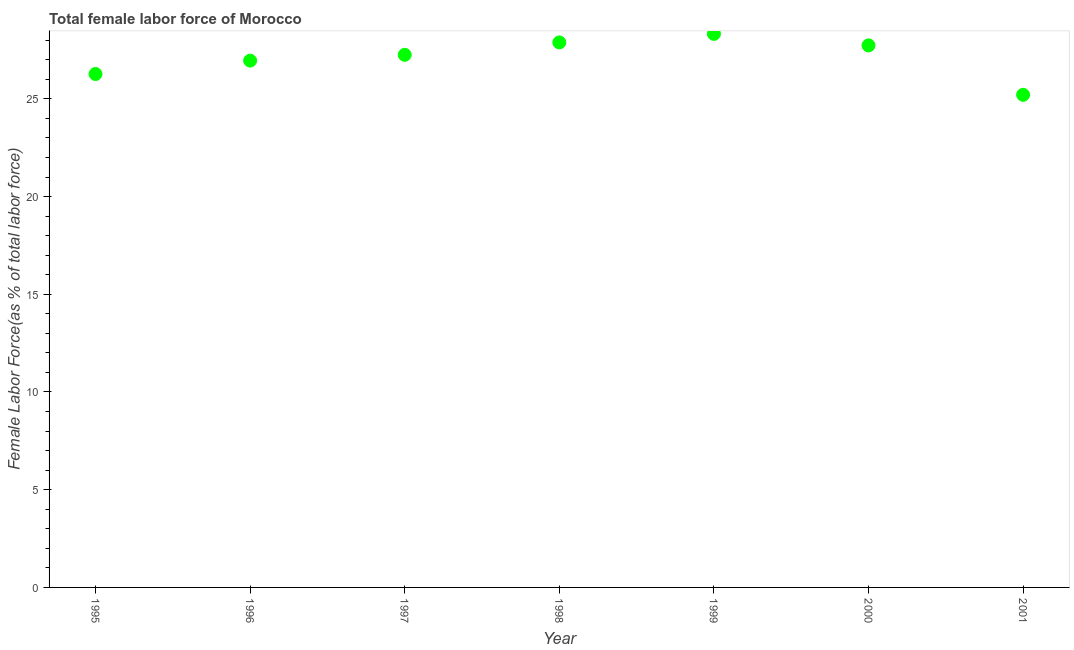What is the total female labor force in 1998?
Your answer should be very brief. 27.89. Across all years, what is the maximum total female labor force?
Offer a very short reply. 28.33. Across all years, what is the minimum total female labor force?
Your answer should be very brief. 25.21. In which year was the total female labor force maximum?
Ensure brevity in your answer.  1999. What is the sum of the total female labor force?
Provide a short and direct response. 189.64. What is the difference between the total female labor force in 1997 and 1998?
Your answer should be compact. -0.64. What is the average total female labor force per year?
Provide a short and direct response. 27.09. What is the median total female labor force?
Offer a very short reply. 27.25. Do a majority of the years between 2001 and 1998 (inclusive) have total female labor force greater than 16 %?
Your response must be concise. Yes. What is the ratio of the total female labor force in 1995 to that in 1999?
Provide a short and direct response. 0.93. Is the total female labor force in 1999 less than that in 2000?
Ensure brevity in your answer.  No. What is the difference between the highest and the second highest total female labor force?
Keep it short and to the point. 0.44. What is the difference between the highest and the lowest total female labor force?
Your response must be concise. 3.12. Does the total female labor force monotonically increase over the years?
Your answer should be very brief. No. How many dotlines are there?
Your answer should be very brief. 1. What is the difference between two consecutive major ticks on the Y-axis?
Provide a short and direct response. 5. Does the graph contain any zero values?
Your answer should be compact. No. Does the graph contain grids?
Offer a very short reply. No. What is the title of the graph?
Provide a succinct answer. Total female labor force of Morocco. What is the label or title of the X-axis?
Provide a short and direct response. Year. What is the label or title of the Y-axis?
Ensure brevity in your answer.  Female Labor Force(as % of total labor force). What is the Female Labor Force(as % of total labor force) in 1995?
Offer a very short reply. 26.27. What is the Female Labor Force(as % of total labor force) in 1996?
Make the answer very short. 26.96. What is the Female Labor Force(as % of total labor force) in 1997?
Your answer should be very brief. 27.25. What is the Female Labor Force(as % of total labor force) in 1998?
Give a very brief answer. 27.89. What is the Female Labor Force(as % of total labor force) in 1999?
Make the answer very short. 28.33. What is the Female Labor Force(as % of total labor force) in 2000?
Provide a short and direct response. 27.74. What is the Female Labor Force(as % of total labor force) in 2001?
Your answer should be compact. 25.21. What is the difference between the Female Labor Force(as % of total labor force) in 1995 and 1996?
Offer a very short reply. -0.69. What is the difference between the Female Labor Force(as % of total labor force) in 1995 and 1997?
Keep it short and to the point. -0.98. What is the difference between the Female Labor Force(as % of total labor force) in 1995 and 1998?
Keep it short and to the point. -1.62. What is the difference between the Female Labor Force(as % of total labor force) in 1995 and 1999?
Provide a short and direct response. -2.05. What is the difference between the Female Labor Force(as % of total labor force) in 1995 and 2000?
Make the answer very short. -1.46. What is the difference between the Female Labor Force(as % of total labor force) in 1995 and 2001?
Ensure brevity in your answer.  1.06. What is the difference between the Female Labor Force(as % of total labor force) in 1996 and 1997?
Keep it short and to the point. -0.3. What is the difference between the Female Labor Force(as % of total labor force) in 1996 and 1998?
Ensure brevity in your answer.  -0.93. What is the difference between the Female Labor Force(as % of total labor force) in 1996 and 1999?
Your answer should be very brief. -1.37. What is the difference between the Female Labor Force(as % of total labor force) in 1996 and 2000?
Offer a terse response. -0.78. What is the difference between the Female Labor Force(as % of total labor force) in 1996 and 2001?
Your response must be concise. 1.75. What is the difference between the Female Labor Force(as % of total labor force) in 1997 and 1998?
Your answer should be compact. -0.64. What is the difference between the Female Labor Force(as % of total labor force) in 1997 and 1999?
Provide a short and direct response. -1.07. What is the difference between the Female Labor Force(as % of total labor force) in 1997 and 2000?
Provide a short and direct response. -0.48. What is the difference between the Female Labor Force(as % of total labor force) in 1997 and 2001?
Offer a very short reply. 2.05. What is the difference between the Female Labor Force(as % of total labor force) in 1998 and 1999?
Your response must be concise. -0.44. What is the difference between the Female Labor Force(as % of total labor force) in 1998 and 2000?
Your response must be concise. 0.15. What is the difference between the Female Labor Force(as % of total labor force) in 1998 and 2001?
Offer a terse response. 2.68. What is the difference between the Female Labor Force(as % of total labor force) in 1999 and 2000?
Your answer should be compact. 0.59. What is the difference between the Female Labor Force(as % of total labor force) in 1999 and 2001?
Make the answer very short. 3.12. What is the difference between the Female Labor Force(as % of total labor force) in 2000 and 2001?
Your answer should be very brief. 2.53. What is the ratio of the Female Labor Force(as % of total labor force) in 1995 to that in 1998?
Ensure brevity in your answer.  0.94. What is the ratio of the Female Labor Force(as % of total labor force) in 1995 to that in 1999?
Offer a terse response. 0.93. What is the ratio of the Female Labor Force(as % of total labor force) in 1995 to that in 2000?
Offer a terse response. 0.95. What is the ratio of the Female Labor Force(as % of total labor force) in 1995 to that in 2001?
Your response must be concise. 1.04. What is the ratio of the Female Labor Force(as % of total labor force) in 1996 to that in 1998?
Offer a very short reply. 0.97. What is the ratio of the Female Labor Force(as % of total labor force) in 1996 to that in 1999?
Offer a very short reply. 0.95. What is the ratio of the Female Labor Force(as % of total labor force) in 1996 to that in 2000?
Your response must be concise. 0.97. What is the ratio of the Female Labor Force(as % of total labor force) in 1996 to that in 2001?
Keep it short and to the point. 1.07. What is the ratio of the Female Labor Force(as % of total labor force) in 1997 to that in 2000?
Provide a short and direct response. 0.98. What is the ratio of the Female Labor Force(as % of total labor force) in 1997 to that in 2001?
Provide a succinct answer. 1.08. What is the ratio of the Female Labor Force(as % of total labor force) in 1998 to that in 2000?
Give a very brief answer. 1. What is the ratio of the Female Labor Force(as % of total labor force) in 1998 to that in 2001?
Offer a terse response. 1.11. What is the ratio of the Female Labor Force(as % of total labor force) in 1999 to that in 2001?
Your answer should be compact. 1.12. What is the ratio of the Female Labor Force(as % of total labor force) in 2000 to that in 2001?
Offer a very short reply. 1.1. 